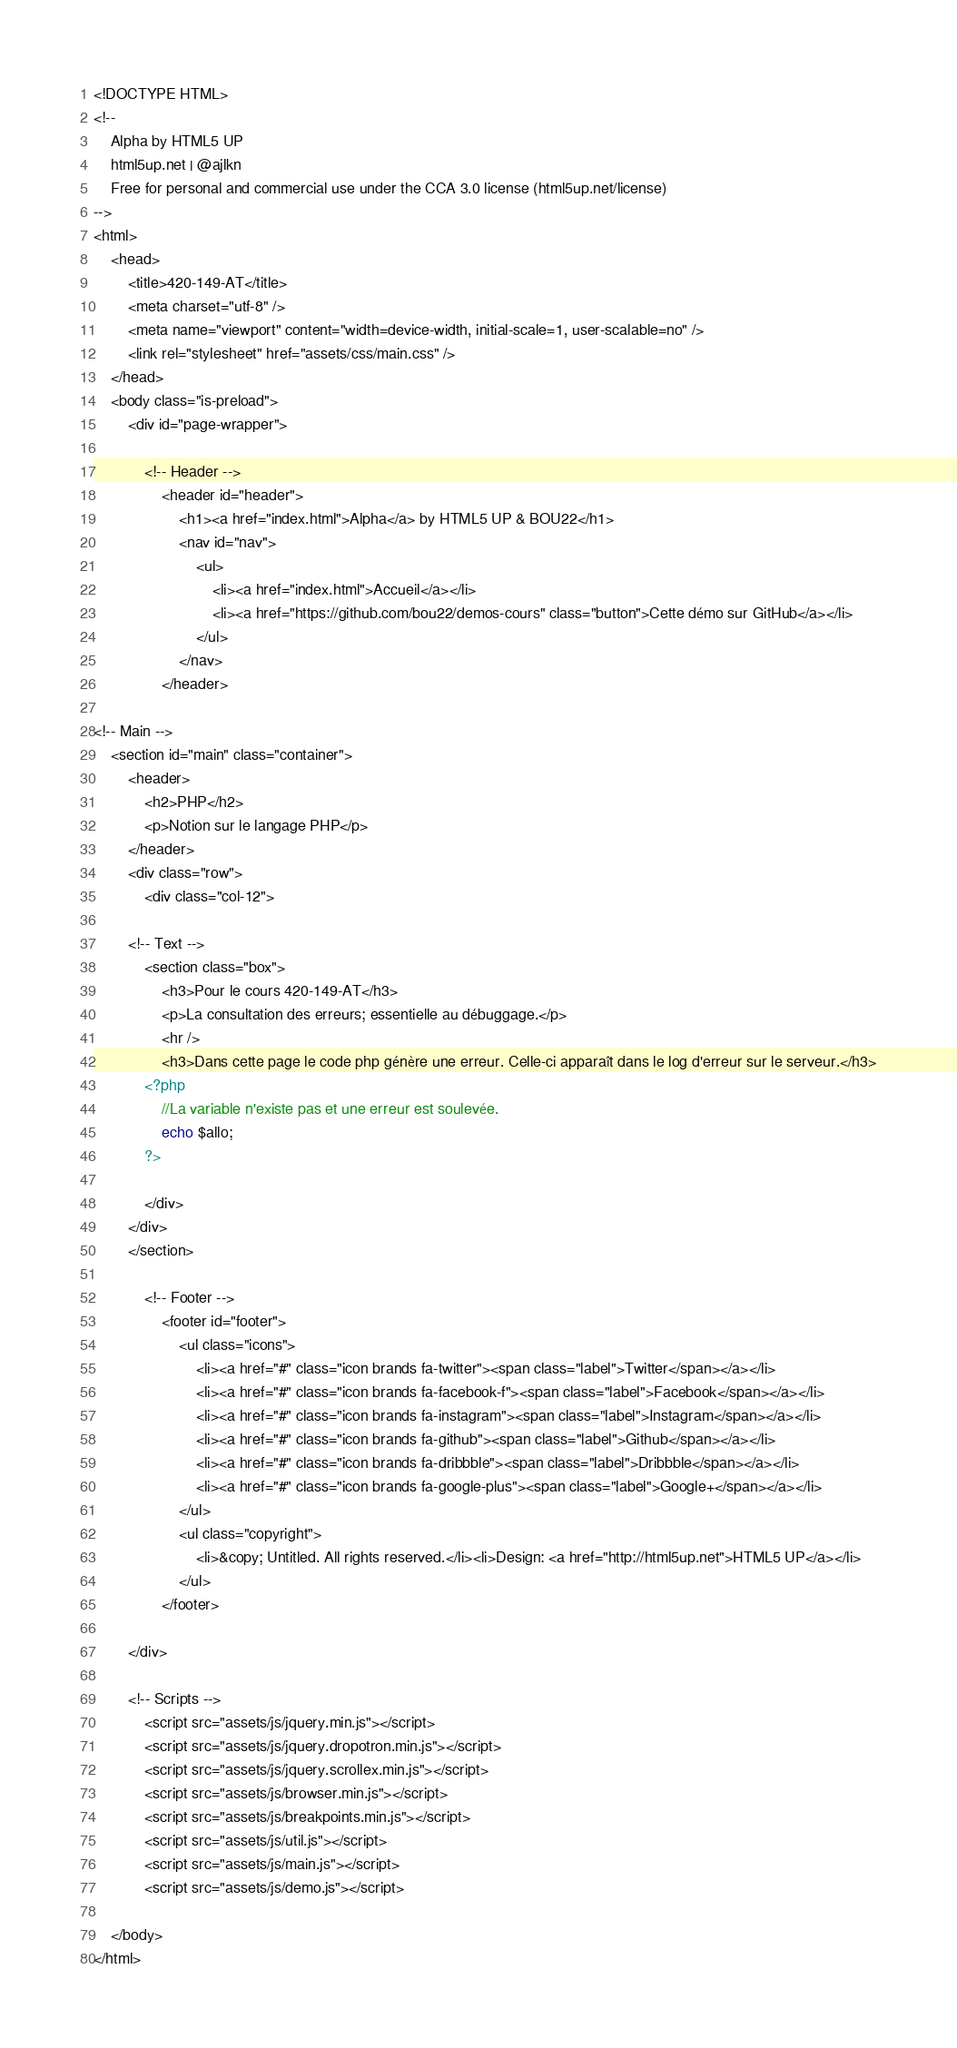Convert code to text. <code><loc_0><loc_0><loc_500><loc_500><_PHP_><!DOCTYPE HTML>
<!--
	Alpha by HTML5 UP
	html5up.net | @ajlkn
	Free for personal and commercial use under the CCA 3.0 license (html5up.net/license)
-->
<html>
	<head>
		<title>420-149-AT</title>
		<meta charset="utf-8" />
		<meta name="viewport" content="width=device-width, initial-scale=1, user-scalable=no" />
		<link rel="stylesheet" href="assets/css/main.css" />
	</head>
	<body class="is-preload">
		<div id="page-wrapper">

			<!-- Header -->
				<header id="header">
					<h1><a href="index.html">Alpha</a> by HTML5 UP & BOU22</h1>
					<nav id="nav">
						<ul>
							<li><a href="index.html">Accueil</a></li>
							<li><a href="https://github.com/bou22/demos-cours" class="button">Cette démo sur GitHub</a></li>
						</ul>
					</nav>
				</header>

<!-- Main -->
    <section id="main" class="container">
        <header>
            <h2>PHP</h2>
            <p>Notion sur le langage PHP</p>
        </header>
        <div class="row">
            <div class="col-12">

        <!-- Text -->
            <section class="box">
                <h3>Pour le cours 420-149-AT</h3>
                <p>La consultation des erreurs; essentielle au débuggage.</p>
                <hr />
                <h3>Dans cette page le code php génère une erreur. Celle-ci apparaît dans le log d'erreur sur le serveur.</h3>
            <?php 
                //La variable n'existe pas et une erreur est soulevée.
                echo $allo;
            ?>

            </div>
        </div>
        </section>

			<!-- Footer -->
				<footer id="footer">
					<ul class="icons">
						<li><a href="#" class="icon brands fa-twitter"><span class="label">Twitter</span></a></li>
						<li><a href="#" class="icon brands fa-facebook-f"><span class="label">Facebook</span></a></li>
						<li><a href="#" class="icon brands fa-instagram"><span class="label">Instagram</span></a></li>
						<li><a href="#" class="icon brands fa-github"><span class="label">Github</span></a></li>
						<li><a href="#" class="icon brands fa-dribbble"><span class="label">Dribbble</span></a></li>
						<li><a href="#" class="icon brands fa-google-plus"><span class="label">Google+</span></a></li>
					</ul>
					<ul class="copyright">
						<li>&copy; Untitled. All rights reserved.</li><li>Design: <a href="http://html5up.net">HTML5 UP</a></li>
					</ul>
				</footer>

		</div>

		<!-- Scripts -->
			<script src="assets/js/jquery.min.js"></script>
			<script src="assets/js/jquery.dropotron.min.js"></script>
			<script src="assets/js/jquery.scrollex.min.js"></script>
			<script src="assets/js/browser.min.js"></script>
			<script src="assets/js/breakpoints.min.js"></script>
			<script src="assets/js/util.js"></script>
			<script src="assets/js/main.js"></script>
            <script src="assets/js/demo.js"></script>

	</body>
</html></code> 